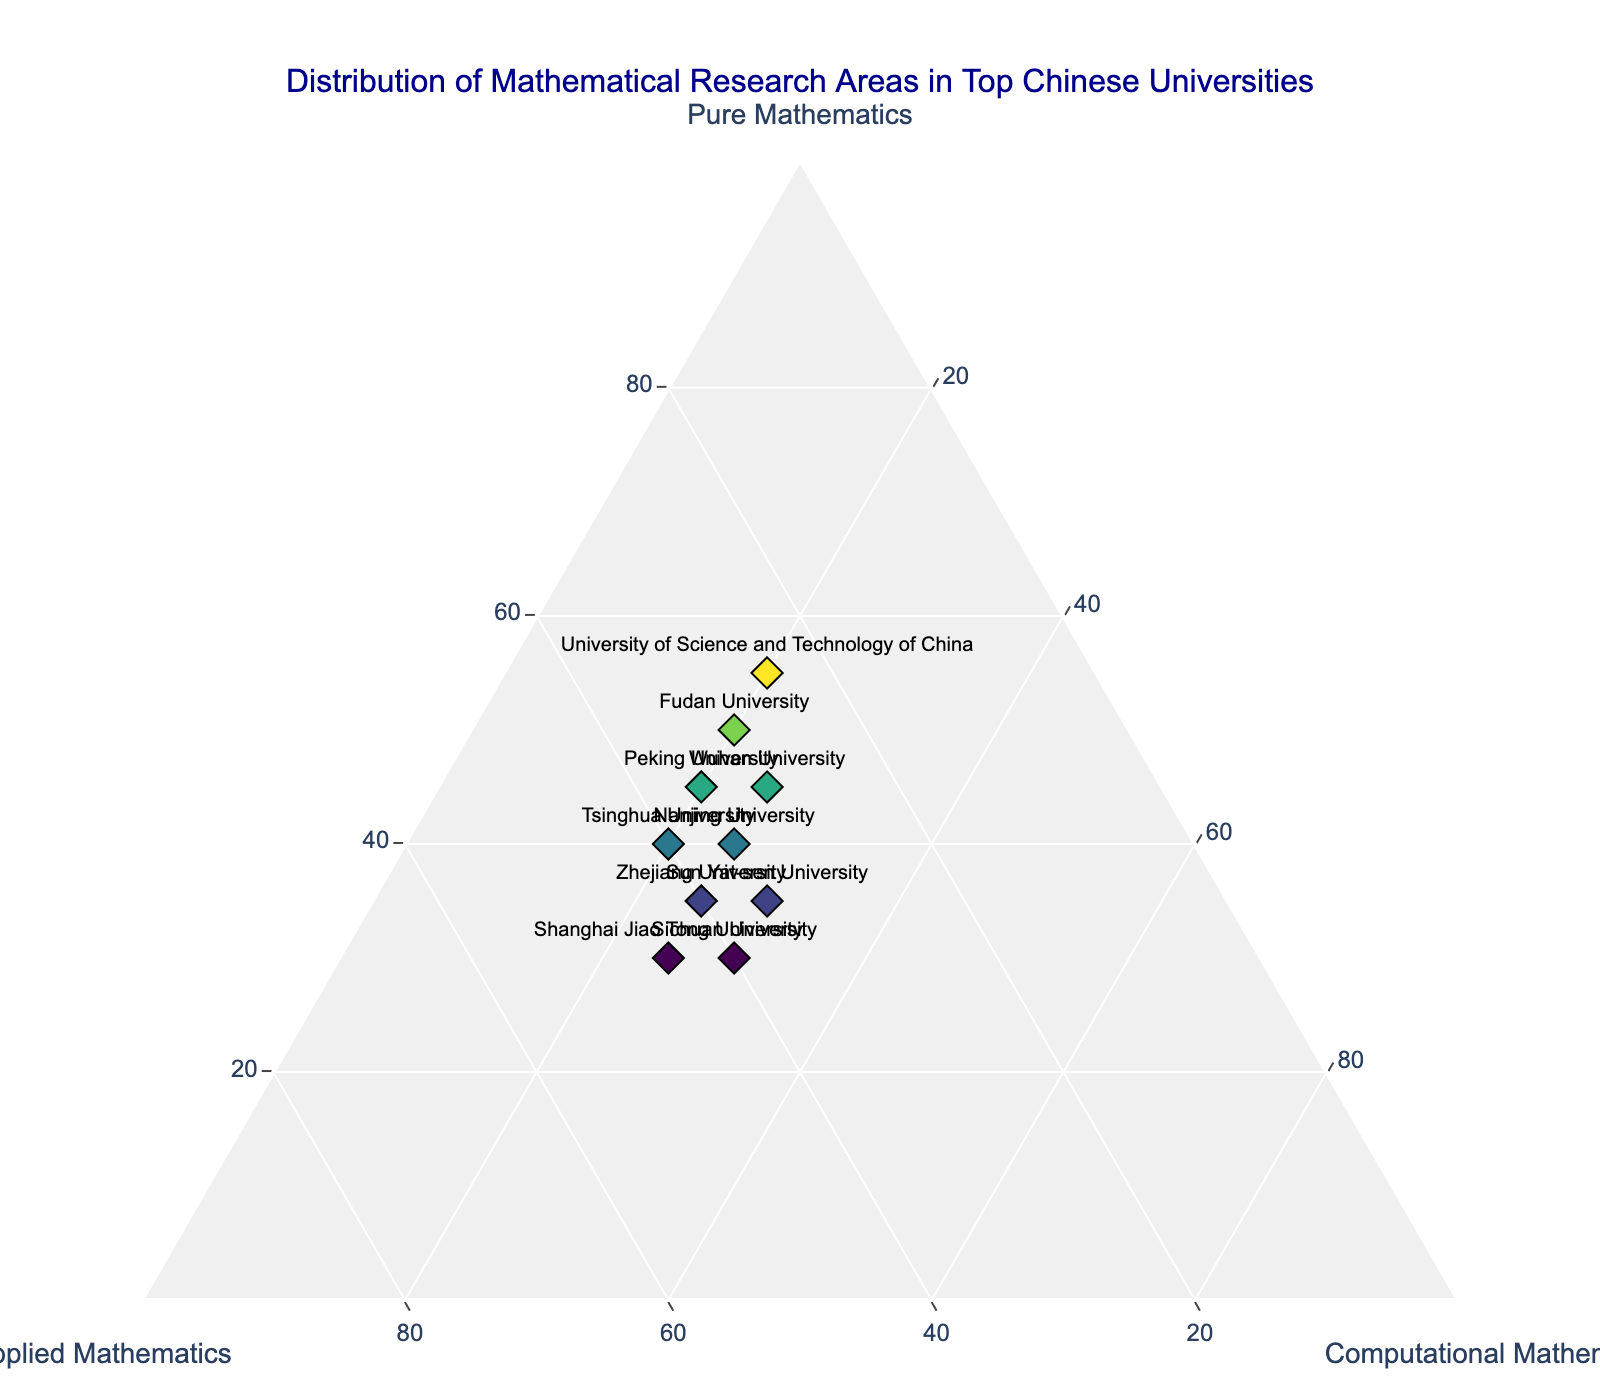What is the title of the plot? The title is prominently displayed at the top of the plot, which provides an introduction to the content being visualized.
Answer: Distribution of Mathematical Research Areas in Top Chinese Universities How many universities are represented in the plot? By counting the number of distinct markers or labels, we can determine the number of universities. There are 10 universities listed in the dataset.
Answer: 10 Which university has the highest percentage of Pure Mathematics research? Identify the markers that are closest to the Pure Mathematics axis. The label closest to the axis with the highest 'a' value is the University of Science and Technology of China.
Answer: University of Science and Technology of China Which two universities have the same percentage of Applied Mathematics research? Look for markers that align horizontally on the Applied Mathematics axis. Both Peking University and Nanjing University have the same percentage (35%) of Applied Mathematics research.
Answer: Peking University and Nanjing University What is the median percentage of Computational Mathematics among the universities? List the percentages of Computational Mathematics for all universities and find the median value. The percentages are [20, 20, 20, 25, 20, 25, 25, 30, 30, 25]. The median of this sorted list is 25%.
Answer: 25% Is there a university that has an equal distribution of all three mathematical research areas? Check for any markers that lie in the center of the ternary plot, indicating equal distribution. No university has an equal percentage (33.33%) in each of the three areas.
Answer: No Which university has the highest percentage of Applied Mathematics research? Identify the marker closest to the Applied Mathematics axis. Shanghai Jiao Tong University has the highest percentage (45%) of Applied Mathematics research.
Answer: Shanghai Jiao Tong University Compare the distribution of mathematical research areas between Tsinghua University and Sun Yat-sen University. Tsinghua University has 40% Pure, 40% Applied, and 20% Computational Mathematics. Sun Yat-sen University has 35% Pure, 35% Applied, and 30% Computational Mathematics. Tsinghua has higher Pure and Applied percentages, while Sun Yat-sen has a higher Computational percentage.
Answer: Tsinghua University: 40% Pure, 40% Applied, 20% Computational; Sun Yat-sen University: 35% Pure, 35% Applied, 30% Computational Which university has the closest research distribution to Fudan University? Compare the distances between the marker of Fudan University and other markers. Zhejiang University (35% Pure, 40% Applied, 25% Computational) is closest to Fudan University (50% Pure, 30% Applied, 20% Computational).
Answer: Zhejiang University What is the sum of the percentages of Pure and Applied Mathematics research for Wuhan University? Add the percentage values for Pure and Applied Mathematics for Wuhan University. Pure Mathematics: 45%, Applied Mathematics: 30%. The sum is 45% + 30% = 75%.
Answer: 75% 